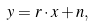<formula> <loc_0><loc_0><loc_500><loc_500>y = r \cdot x + n ,</formula> 